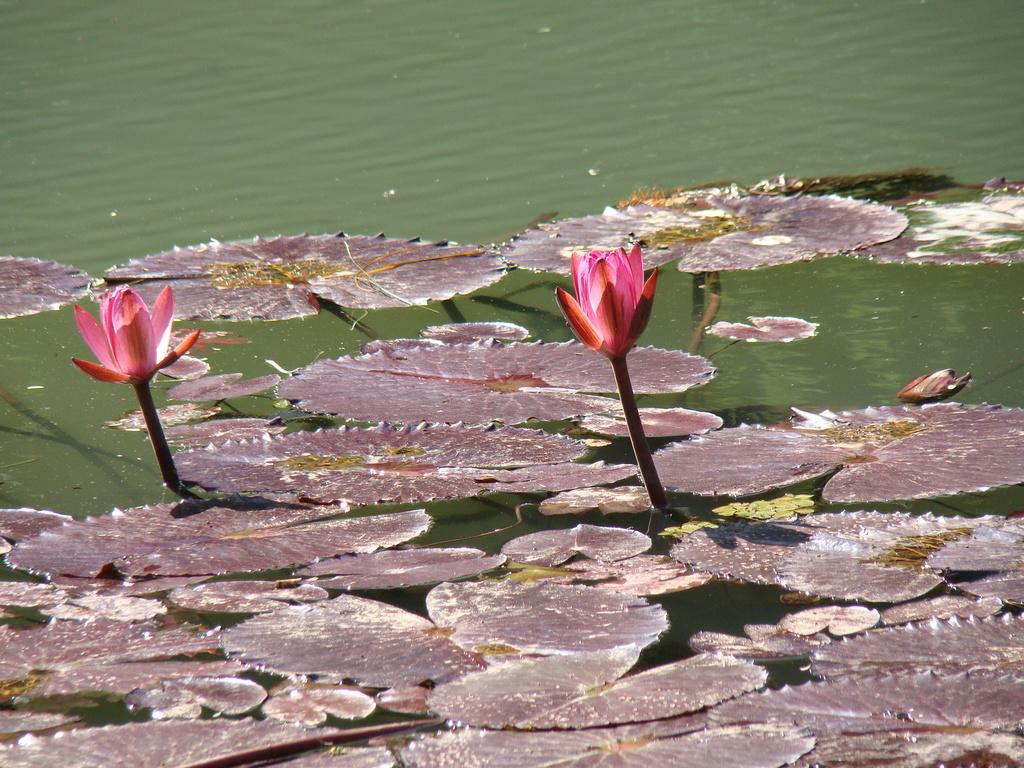What is visible at the bottom of the image? There is water visible at the bottom of the image. What is floating on the water in the image? Leaves and flowers are visible at the top of the water. Can you describe the vegetation present in the image? The vegetation includes leaves and flowers. What type of organization is depicted in the image? There is no organization present in the image; it features water, leaves, and flowers. How many dogs can be seen swimming in the water in the image? There are no dogs present in the image. 